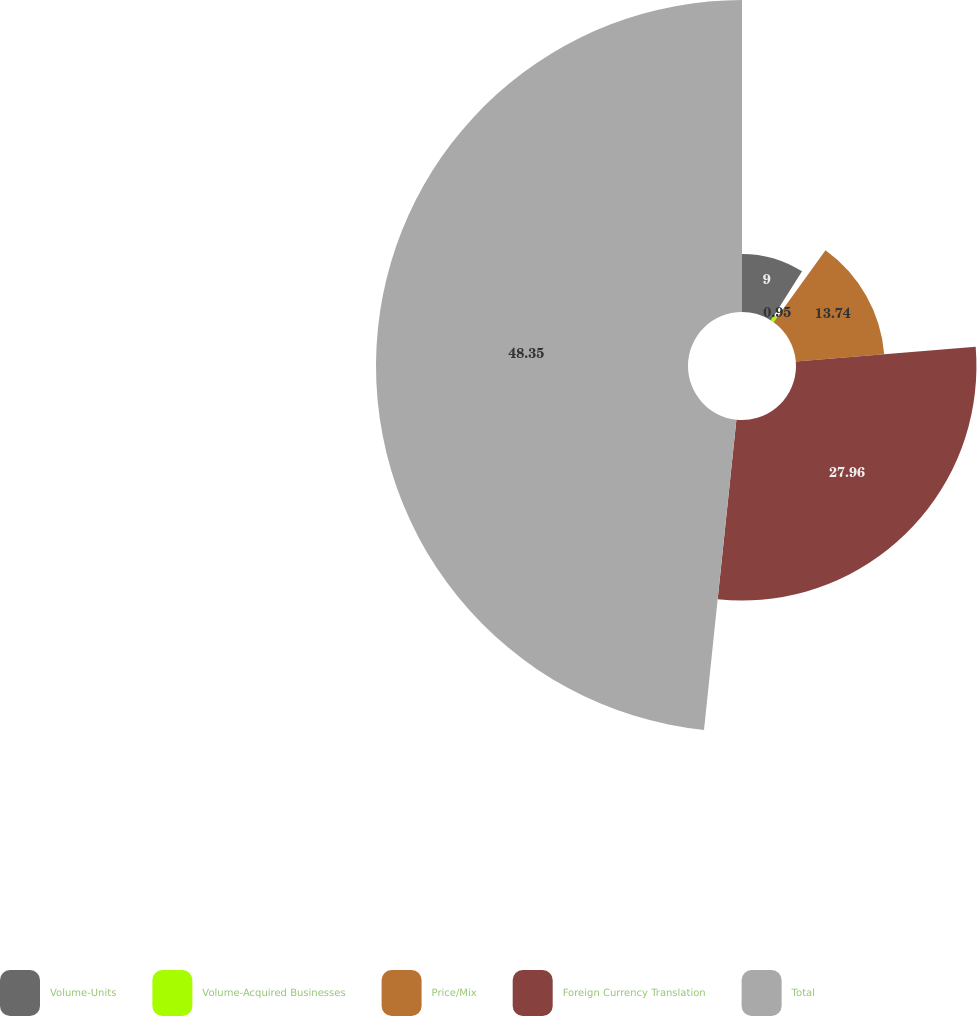Convert chart. <chart><loc_0><loc_0><loc_500><loc_500><pie_chart><fcel>Volume-Units<fcel>Volume-Acquired Businesses<fcel>Price/Mix<fcel>Foreign Currency Translation<fcel>Total<nl><fcel>9.0%<fcel>0.95%<fcel>13.74%<fcel>27.96%<fcel>48.34%<nl></chart> 